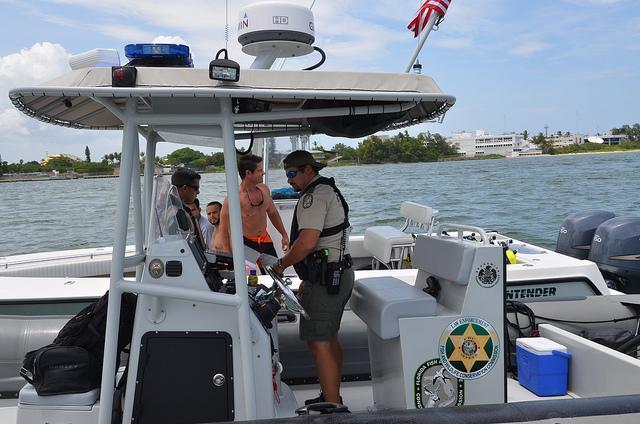How many flags are there?
Give a very brief answer. 1. How many boats are there?
Give a very brief answer. 2. How many people can you see?
Give a very brief answer. 2. 